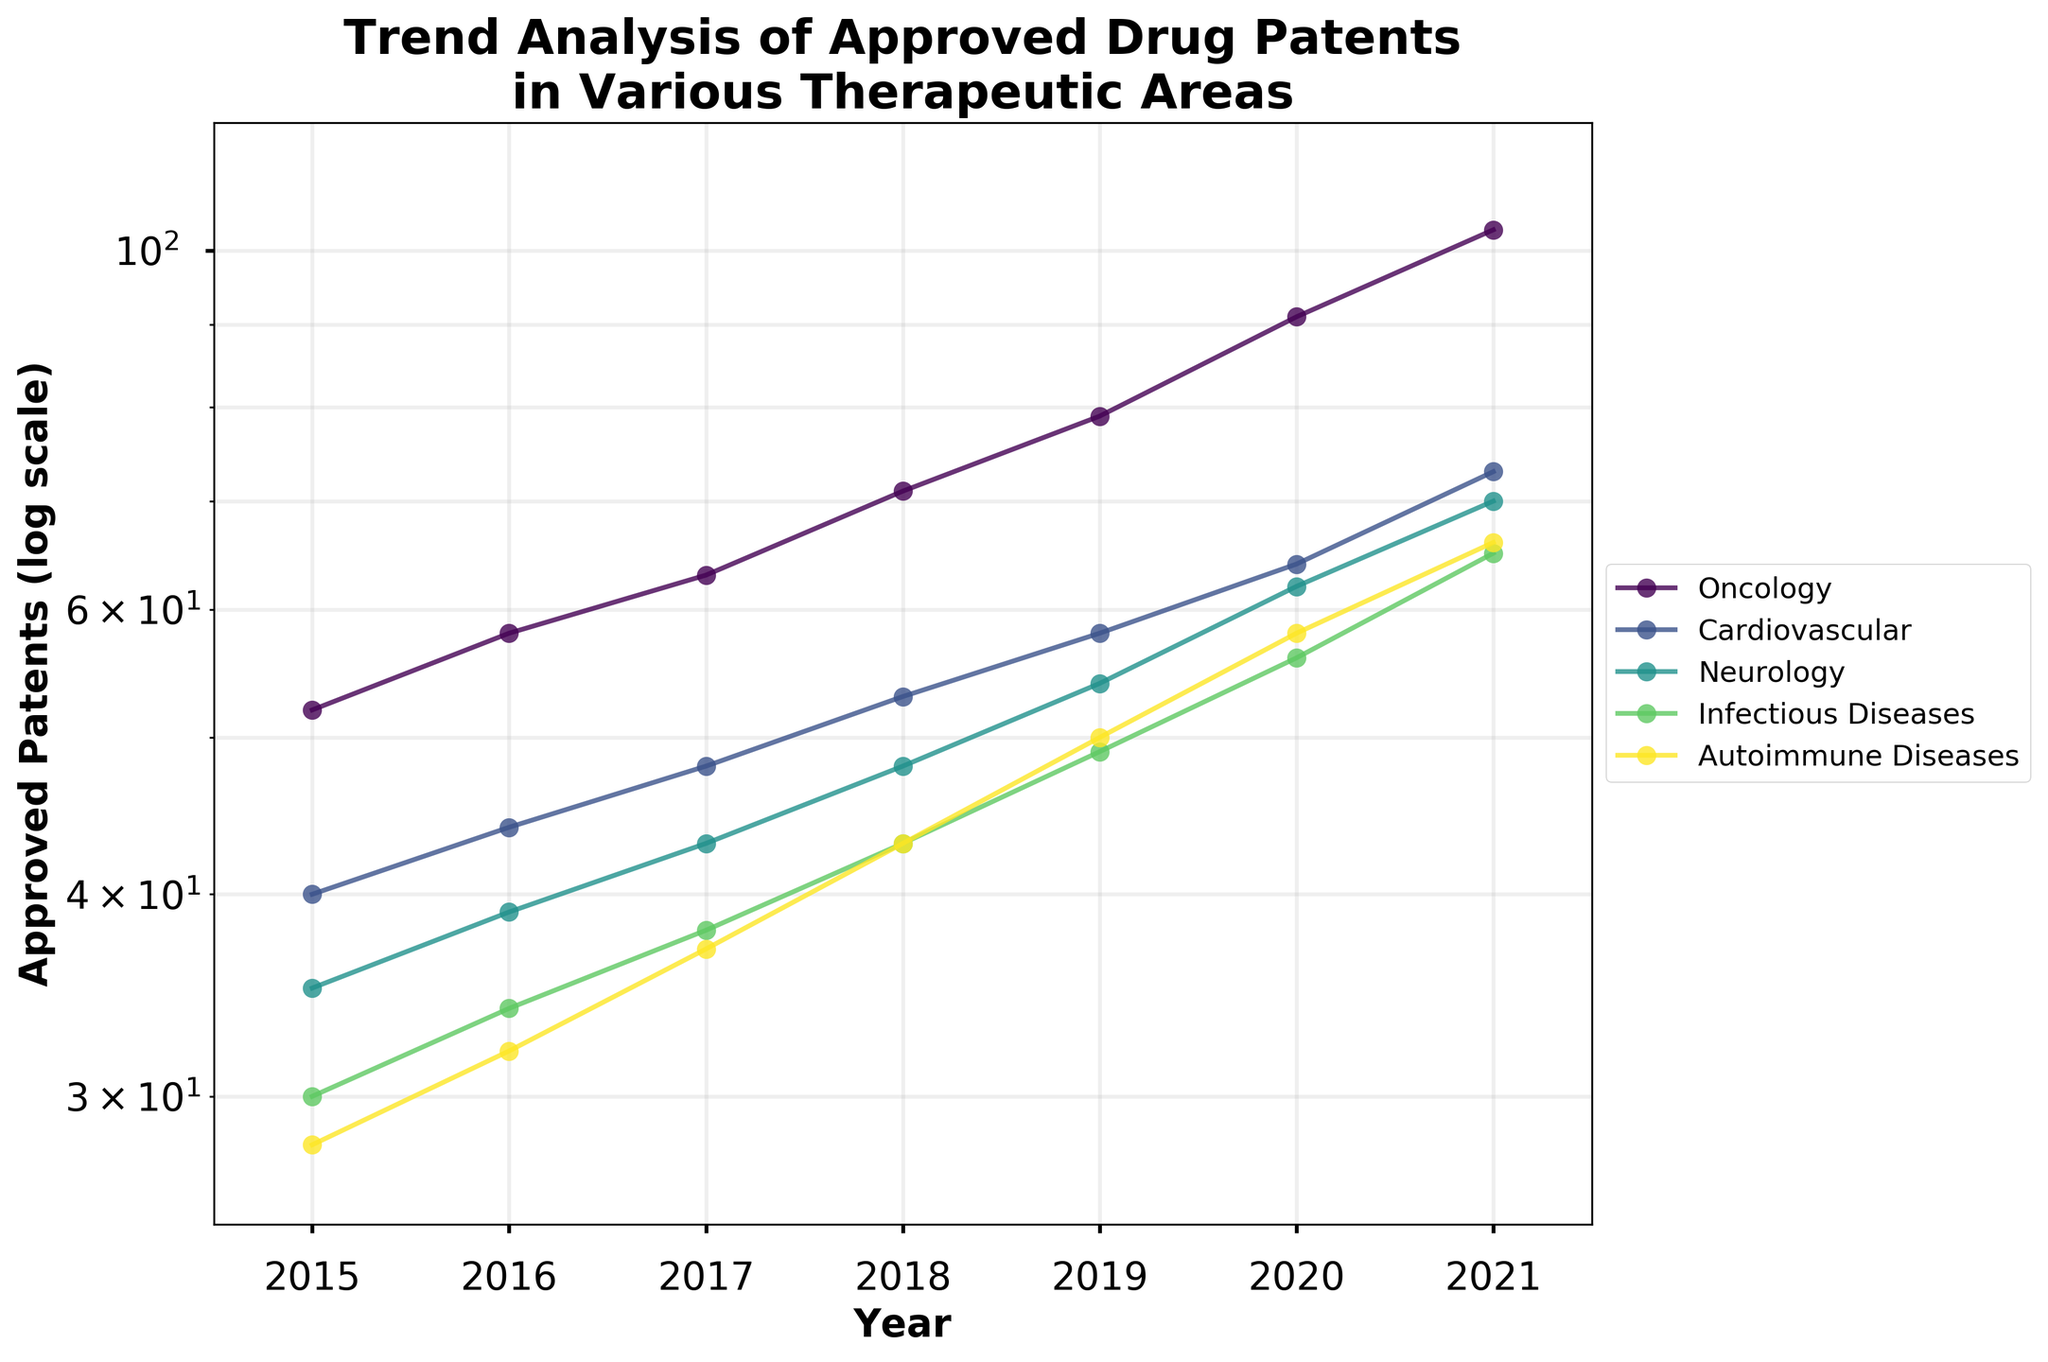what is the title of the figure? The title of the figure is displayed at the top, which helps to understand the context of the data being presented. The title is "Trend Analysis of Approved Drug Patents in Various Therapeutic Areas".
Answer: Trend Analysis of Approved Drug Patents in Various Therapeutic Areas where is the legend positioned in the plot? The legend shows which color corresponds to which therapeutic area, and it's positioned outside the plot area on the right-hand side for clarity.
Answer: Outside the plot on the right-hand side how does the trend for oncology patents compare to autoimmune diseases over the years? To compare trends, look at the lines representing oncology and autoimmune diseases. Oncology has consistently more approved patents than autoimmune diseases from 2015 to 2021. The gap widens as time progresses.
Answer: Oncology has consistently more approved patents, with the gap widening over time which therapeutic area had the lowest number of approved patents in 2015? By checking the vertical position of the points for 2015, we can identify that autoimmune diseases had the lowest number of approved patents, starting at 28 patents.
Answer: Autoimmune Diseases how many therapeutic areas have more than 60 patents approved in 2021? Check the position of the points for 2021 across the therapeutic areas. Oncology, cardiovascular, neurology, infectious diseases, and autoimmune diseases all exceed 60 patents. That's 5 therapeutic areas.
Answer: 5 what is the range of approved patents in 2017 across all therapeutic areas? Find the highest and lowest points in 2017. Oncology has the highest at 63, and autoimmune diseases have the lowest at 37. The range is 63 - 37 = 26 patents.
Answer: 26 patents which therapeutic area shows the steepest increase in approved patents from 2015 to 2021? The steepest increase can be assessed by the slope of the lines. Oncology starts at 52 and ends at 103, with an increase of 51. Compare this to other areas. Oncology shows the steepest increase.
Answer: Oncology what is the average number of approved patents in 2019 across therapeutic areas? Add the 2019 values for all areas: (79+58+54+49+50) = 290. Divide by the number of areas, which is 5. 290/5 = 58.
Answer: 58 